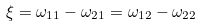Convert formula to latex. <formula><loc_0><loc_0><loc_500><loc_500>\xi = \omega _ { 1 1 } - \omega _ { 2 1 } = \omega _ { 1 2 } - \omega _ { 2 2 }</formula> 